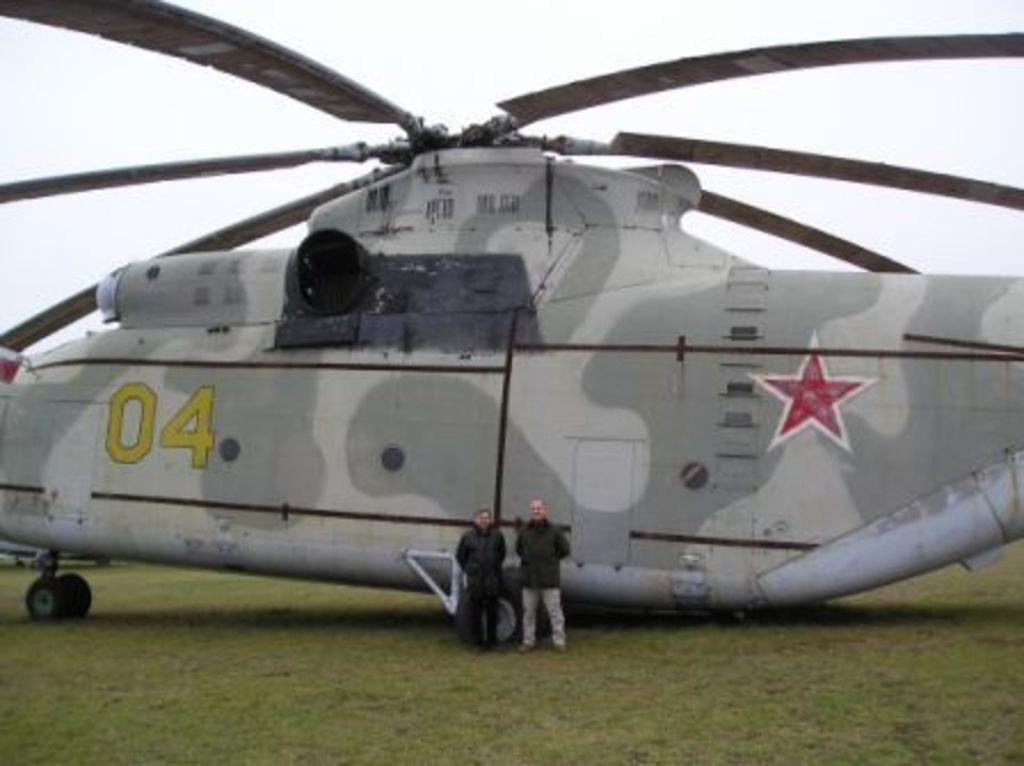<image>
Render a clear and concise summary of the photo. A helicopter with the numbers 04 written on the side 